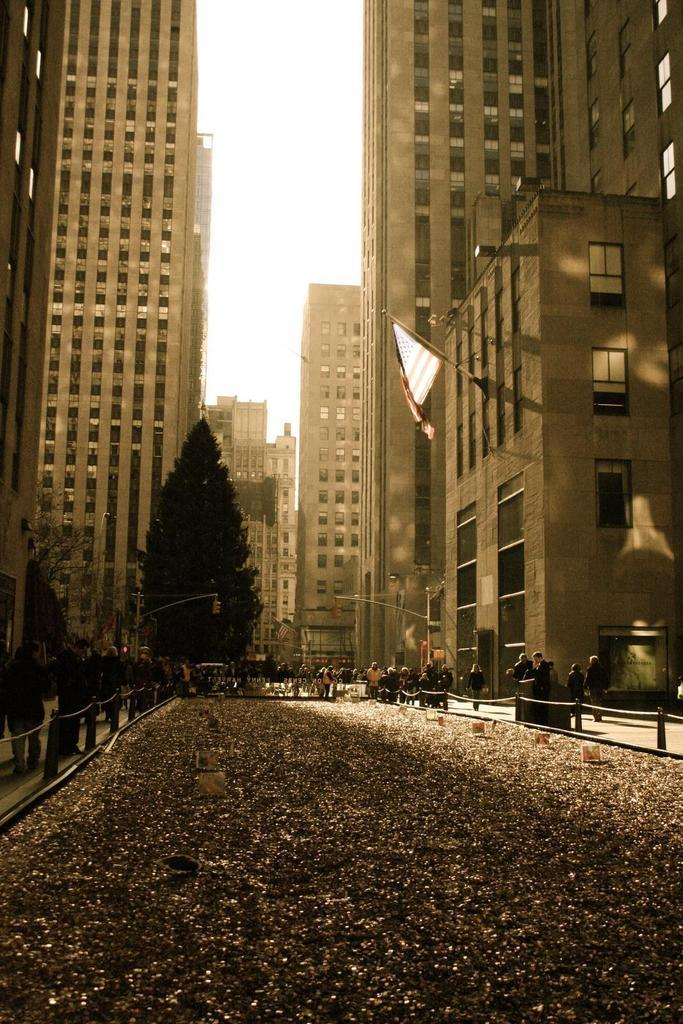What is the main subject of the image? The main subject of the image is a way. What can be seen on either side of the way? There are people and fences on either side of the way. What is visible in the background of the image? There are buildings, trees, and people in the background of the image. What type of picture is hanging on the fence in the image? There is no picture hanging on the fence in the image. Can you recite the verse that is written on the buildings in the background? There is no verse written on the buildings in the background of the image. 